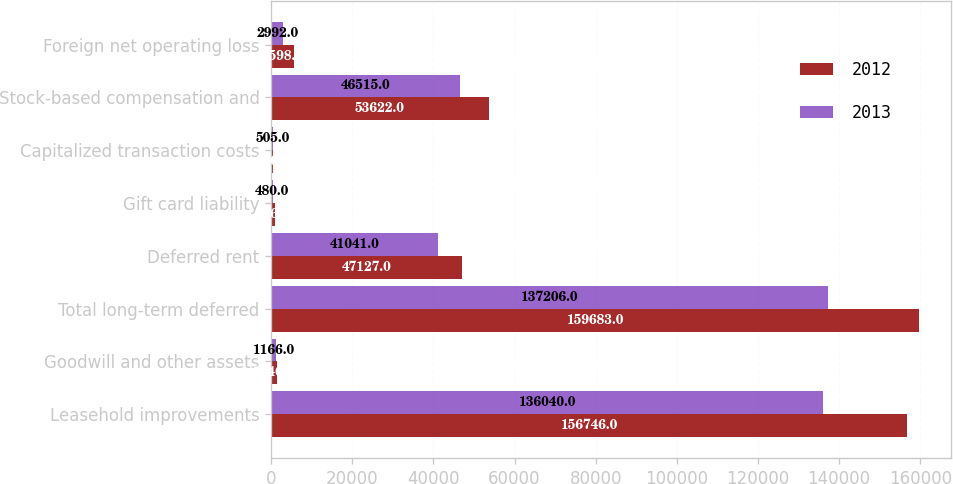<chart> <loc_0><loc_0><loc_500><loc_500><stacked_bar_chart><ecel><fcel>Leasehold improvements<fcel>Goodwill and other assets<fcel>Total long-term deferred<fcel>Deferred rent<fcel>Gift card liability<fcel>Capitalized transaction costs<fcel>Stock-based compensation and<fcel>Foreign net operating loss<nl><fcel>2012<fcel>156746<fcel>1346<fcel>159683<fcel>47127<fcel>876<fcel>506<fcel>53622<fcel>5598<nl><fcel>2013<fcel>136040<fcel>1166<fcel>137206<fcel>41041<fcel>480<fcel>505<fcel>46515<fcel>2992<nl></chart> 